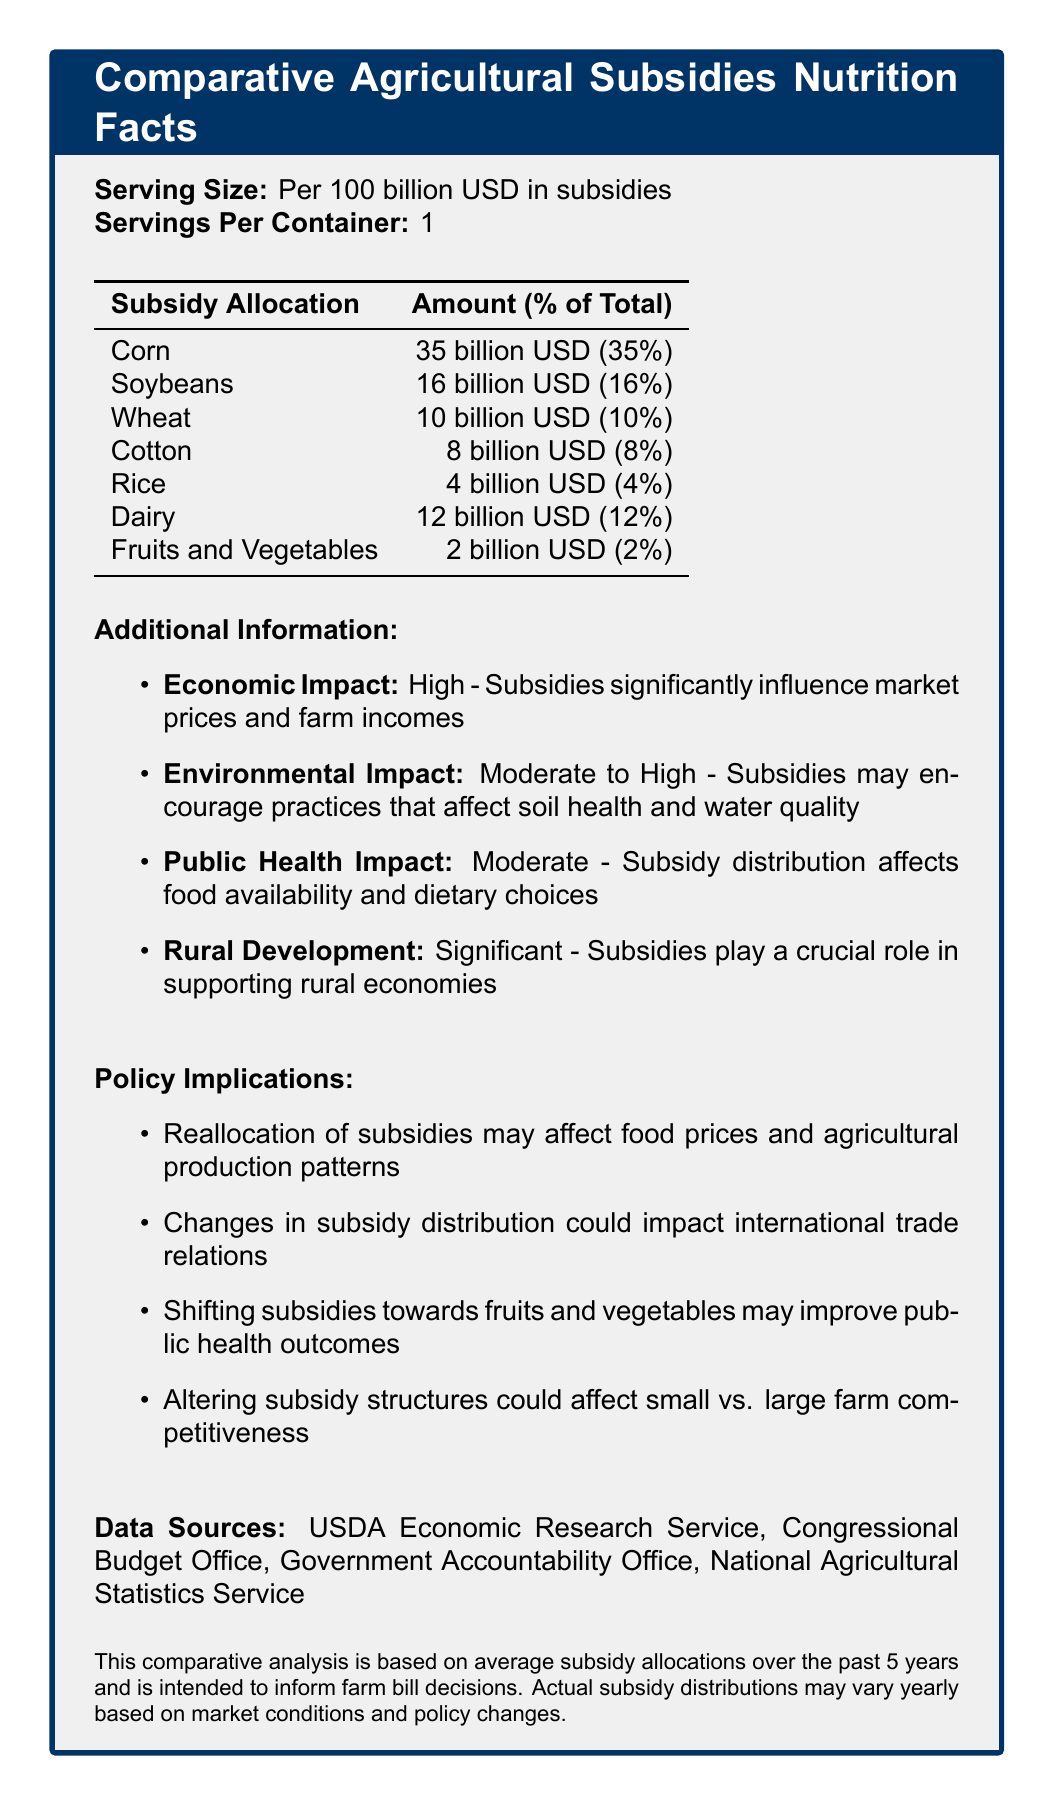what is the product name? The product name is clearly stated at the top of the document.
Answer: Comparative Agricultural Subsidies Nutrition Facts what is the serving size? The serving size is mentioned right under the product name as "Per 100 billion USD in subsidies."
Answer: Per 100 billion USD in subsidies how much subsidy is allocated to corn? The document shows that Corn receives 35 billion USD, which is 35% of the total subsidies.
Answer: 35 billion USD (35%) how much subsidy is allocated to dairy? According to the table, Dairy receives 12 billion USD in subsidies, making up 12% of the total.
Answer: 12 billion USD (12%) how much subsidy is allocated to fruits and vegetables? The table indicates that Fruits and Vegetables receive 2 billion USD, constituting 2% of the total subsidies.
Answer: 2 billion USD (2%) what are the policy implications mentioned in the document? The document lists four policy implications, which include various effects of reallocating subsidies.
Answer: Reallocation of subsidies may affect food prices and agricultural production patterns; Changes in subsidy distribution could impact international trade relations; Shifting subsidies towards fruits and vegetables may improve public health outcomes; Altering subsidy structures could affect small vs. large farm competitiveness which agricultural product receives the smallest amount of subsidies? A. Rice B. Fruits and Vegetables C. Cotton The table shows that Fruits and Vegetables receive the smallest amount of subsidies, totaling 2 billion USD.
Answer: B. Fruits and Vegetables what is the economic impact of the subsidies? The document specifies that the subsidies have a high economic impact, significantly influencing market prices and farm incomes.
Answer: High what is the environmental impact of the subsidies? A. Low B. Moderate C. Moderate to High D. High The document states that the environmental impact of the subsidies ranges from moderate to high.
Answer: C. Moderate to High is the public health impact of subsidy distribution high? The public health impact is stated as "Moderate" in the document.
Answer: No summarize the main idea of the document. The document aims to inform farm bill decisions by comparing the subsidies allocated to different agricultural products, discussing the broader impacts these subsidies have, and providing policy implications for potential reallocation.
Answer: The document provides a comparative analysis of agricultural subsidies, detailing subsidy allocations for various crops, their economic, environmental, and public health impacts, as well as policy implications. The analysis is meant to inform farm bill decisions and highlights the various consequences of reallocation of subsidies. what is the exact numerical total of subsidies allocated among all products? The document gives percentages, but not the exact numerical total of the subsidies.
Answer: Not enough information what is one likely outcome if subsidies are shifted towards fruits and vegetables? The policy implications section indicates that shifting subsidies towards fruits and vegetables may improve public health outcomes.
Answer: Improved public health outcomes 